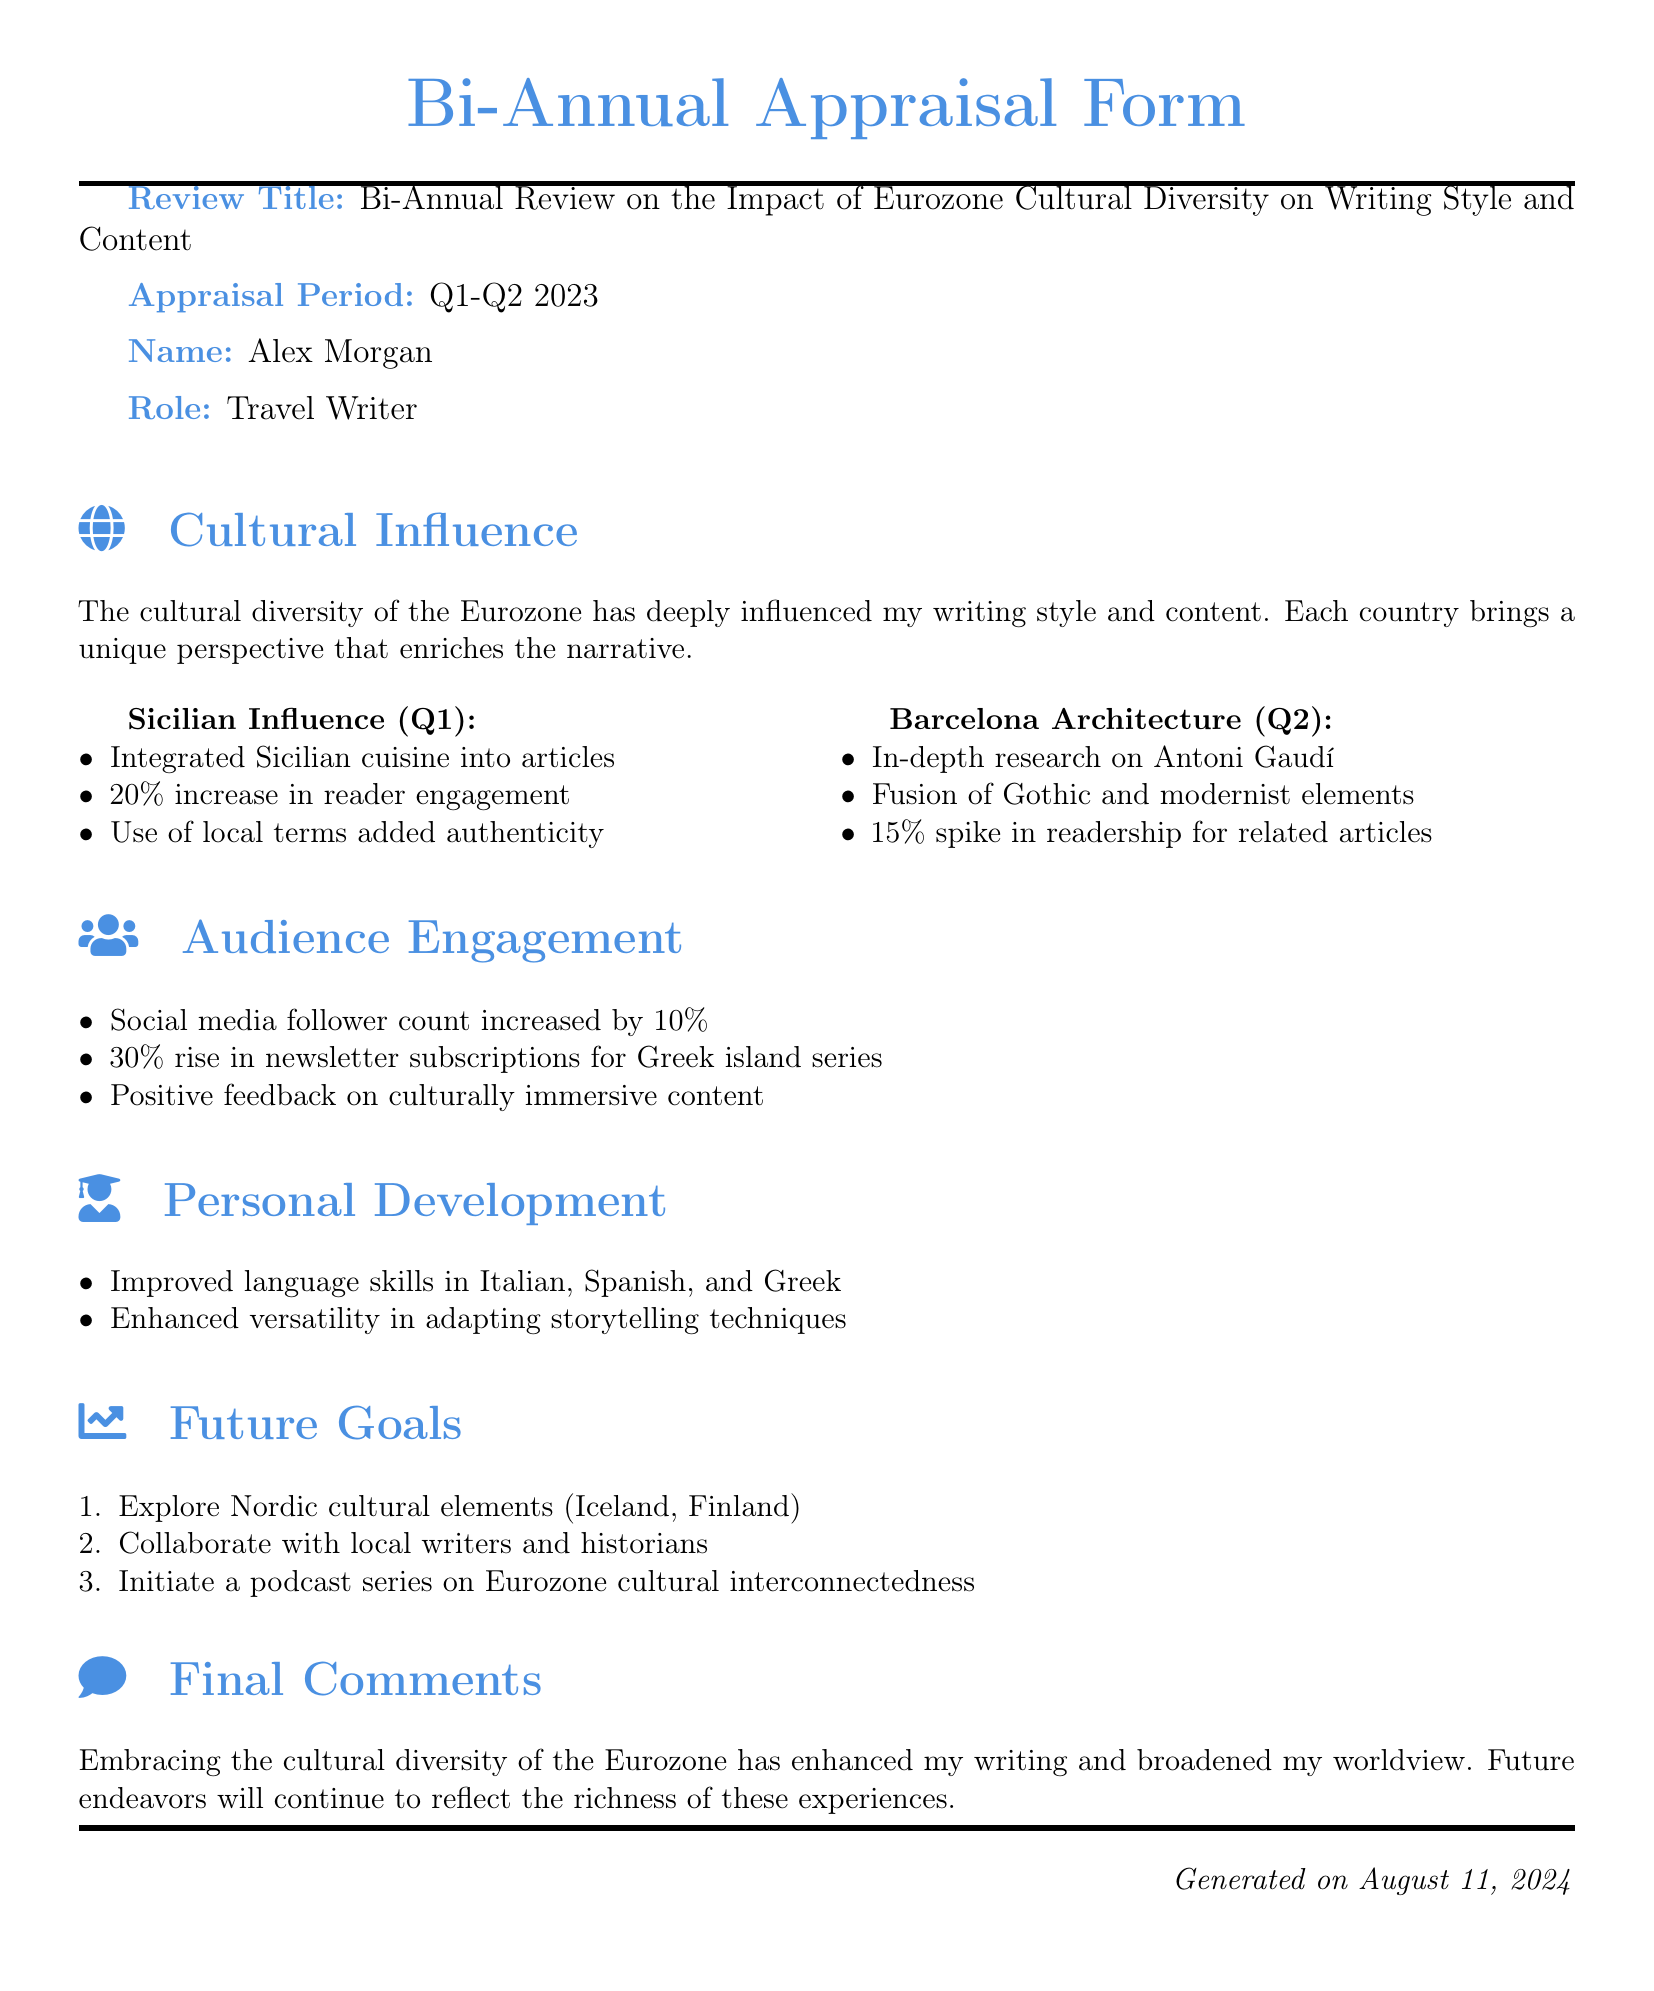What is the review title? The review title is explicitly mentioned at the beginning of the document as the subject of the appraisal.
Answer: Bi-Annual Review on the Impact of Eurozone Cultural Diversity on Writing Style and Content What is the appraisal period? The appraisal period specifies the timeframe for which the review is conducted, listed in an item.
Answer: Q1-Q2 2023 Who is the travel writer? The travel writer's name is given in the document under the name section.
Answer: Alex Morgan What percentage increase in reader engagement resulted from Sicilian influence? The document notes a specific percentage increase directly attributed to the Sicilian influence on writing.
Answer: 20% What cultural aspect was researched in Q2? The document highlights a specific cultural topic under the Barcelona section related to architectural influence in Q2.
Answer: Antoni Gaudí What is the rise in social media followers? The document mentions a percentage increase in social media followers, illustrating audience engagement.
Answer: 10% What are the intended future goals regarding Nordic culture? This question asks for a specific goal mentioned in the future goals section of the document, pertaining to cultural exploration.
Answer: Explore Nordic cultural elements How does the author feel about the impact of cultural diversity on their writing? The final comments section expresses the author's viewpoint on cultural diversity's influence on their writing and perspective.
Answer: Enhanced my writing and broadened my worldview What positive feedback trend was noted regarding the content? This question seeks to retrieve information about the feedback noted for audience engagement in the document.
Answer: Culturally immersive content 